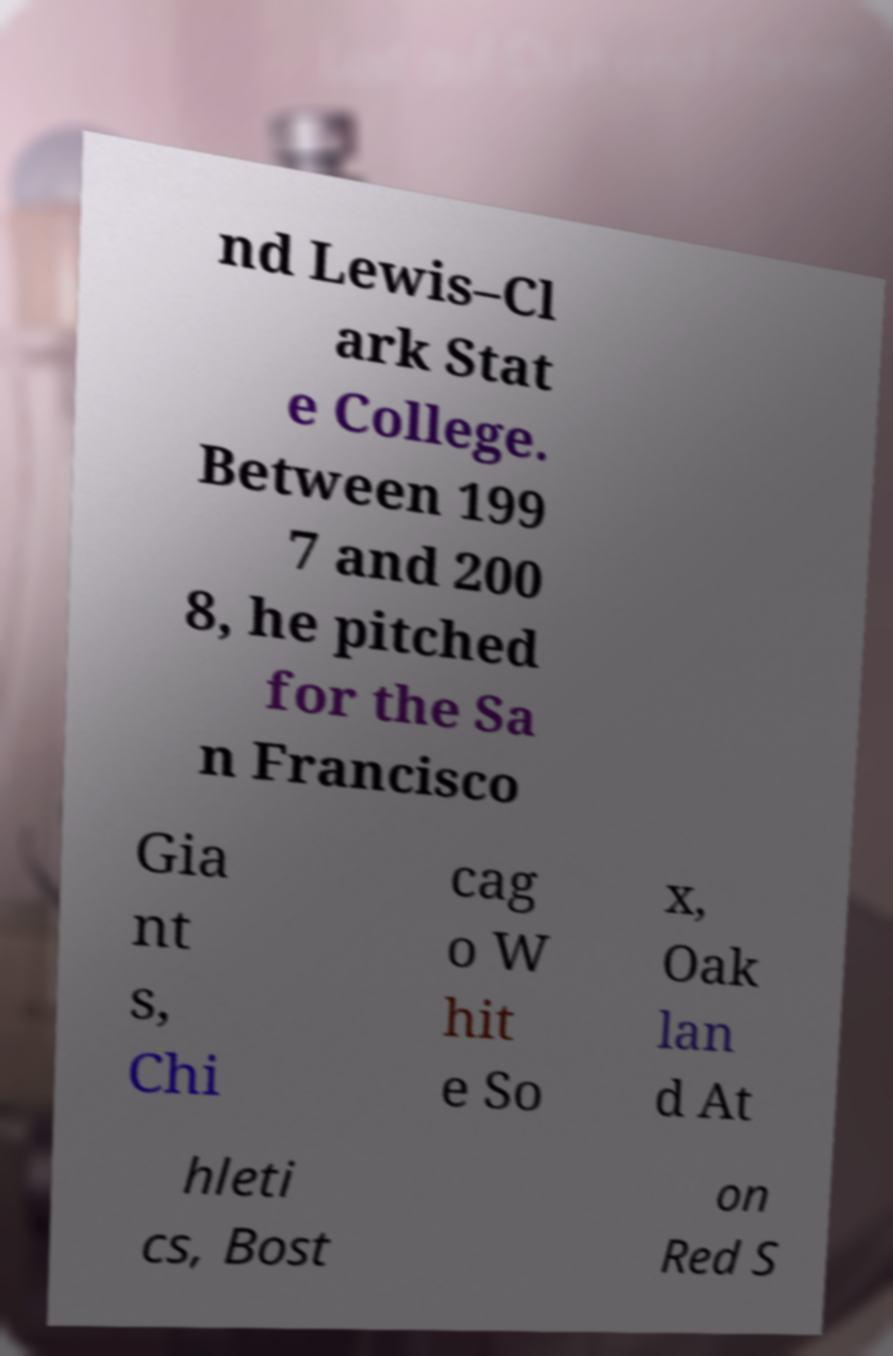What messages or text are displayed in this image? I need them in a readable, typed format. nd Lewis–Cl ark Stat e College. Between 199 7 and 200 8, he pitched for the Sa n Francisco Gia nt s, Chi cag o W hit e So x, Oak lan d At hleti cs, Bost on Red S 